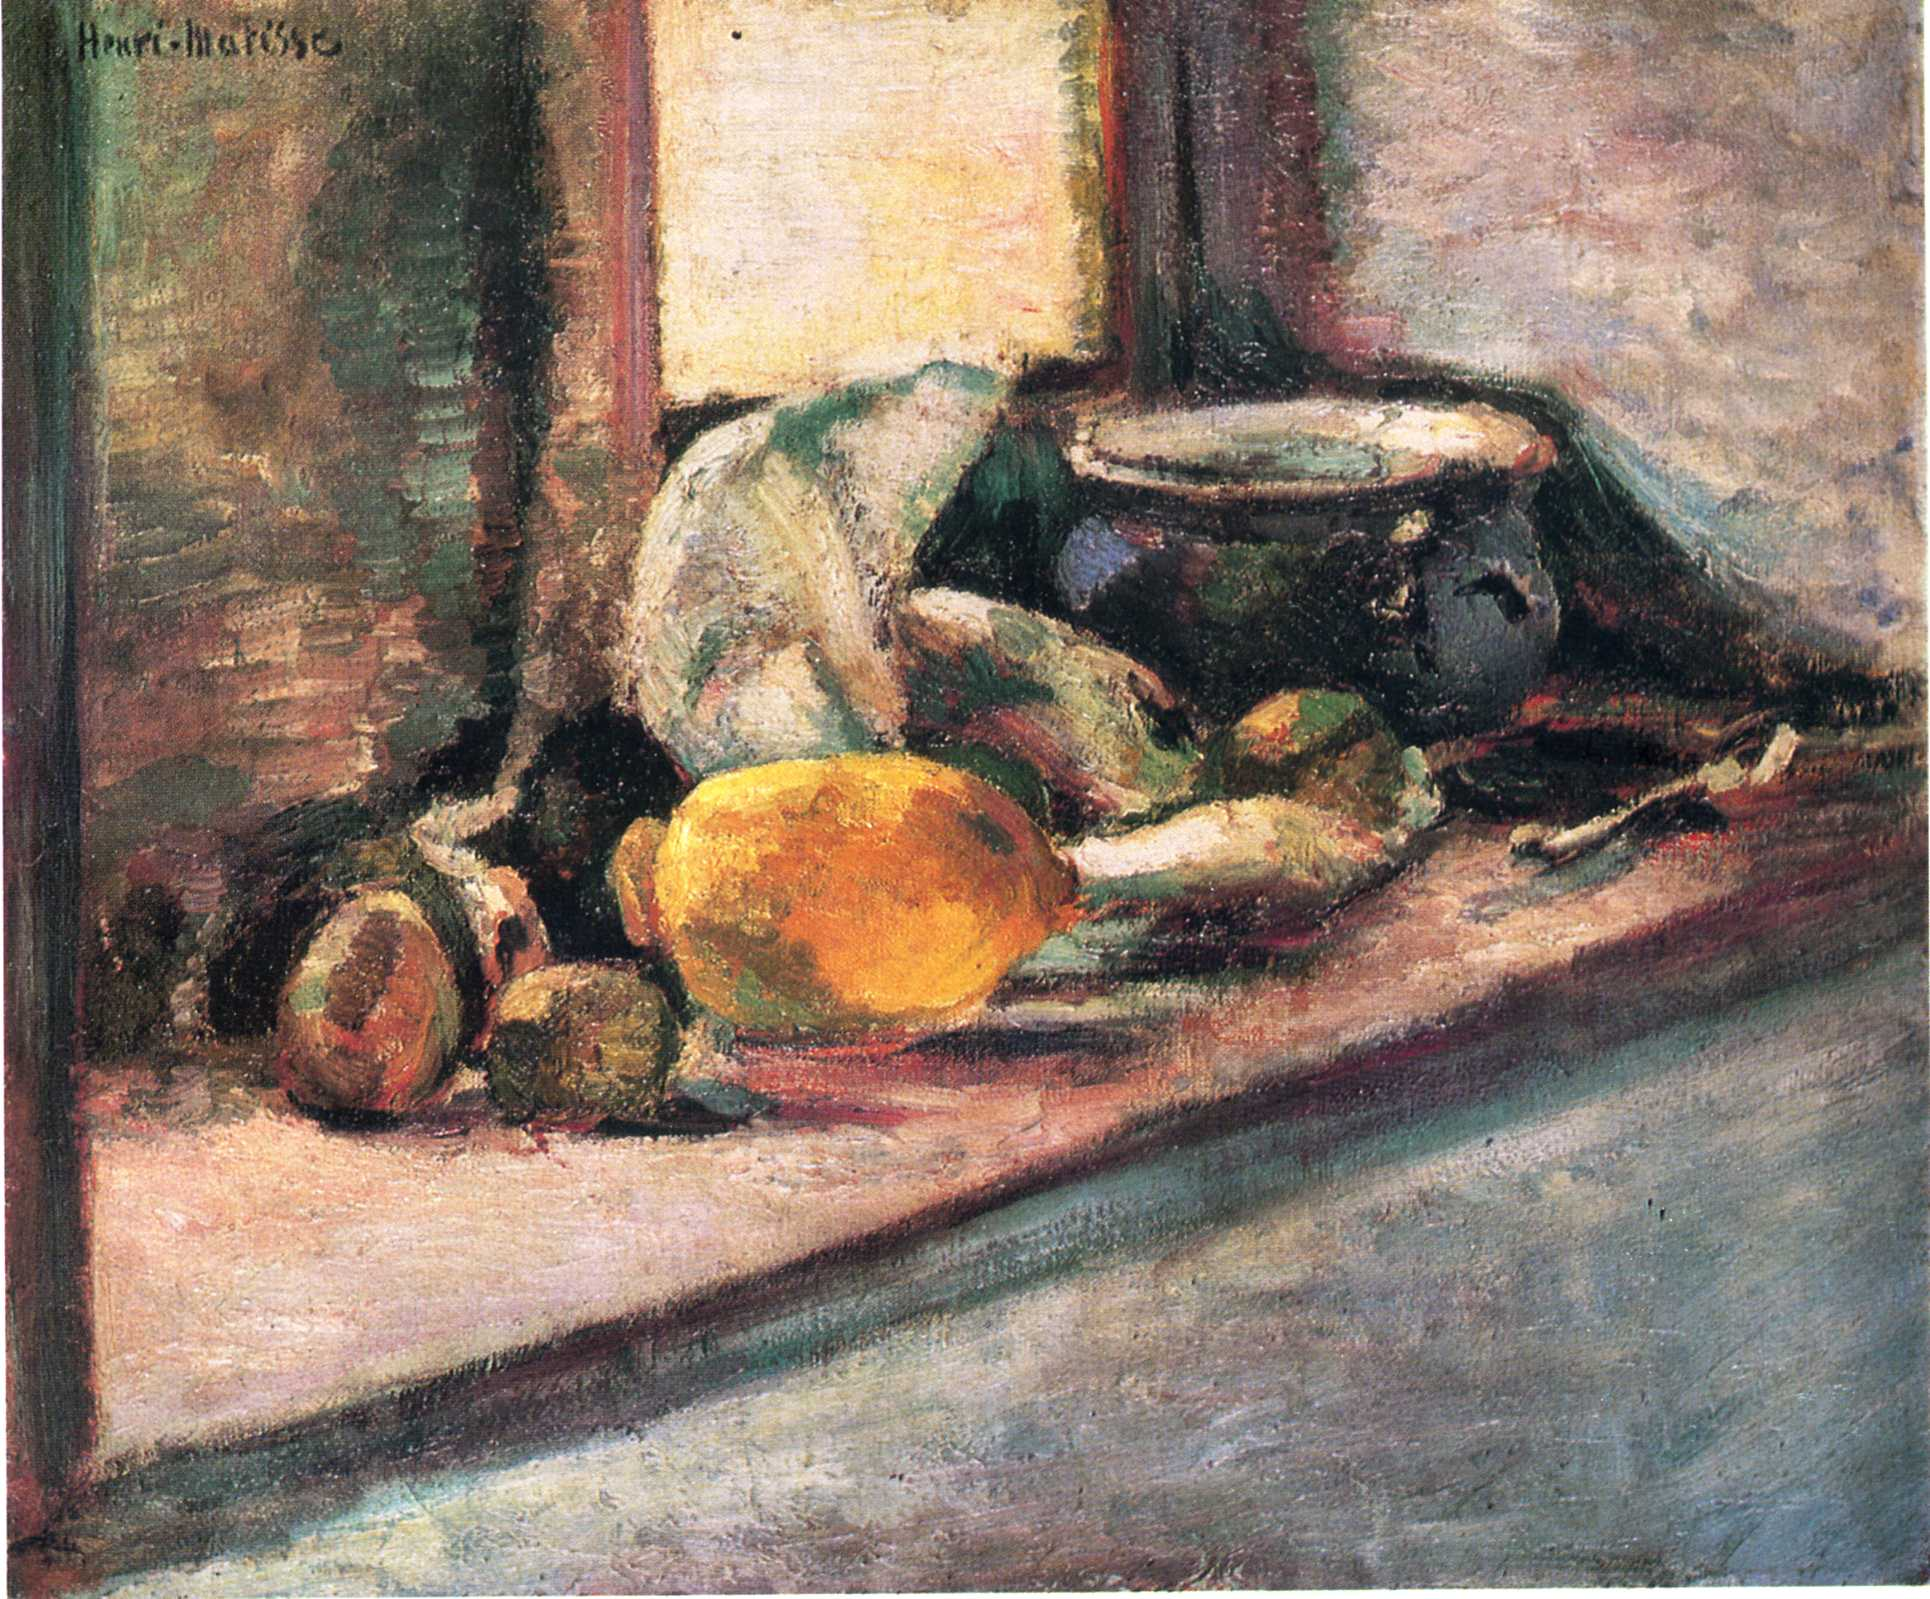How do the colors used in this painting influence its overall mood? The colors Matisse chose for this painting play a crucial role in setting its mood. The warm, vibrant oranges and yellows, alongside the cooler greens and muted background, create a dynamic yet harmonious atmosphere. This palette evokes a sense of warmth and comfort, typical of a serene, domestic setting. The interplay of light and dark shades adds depth, suggesting both the physical light of the setting and an emotional lightness, conveying a peaceful everyday moment captured in time. 